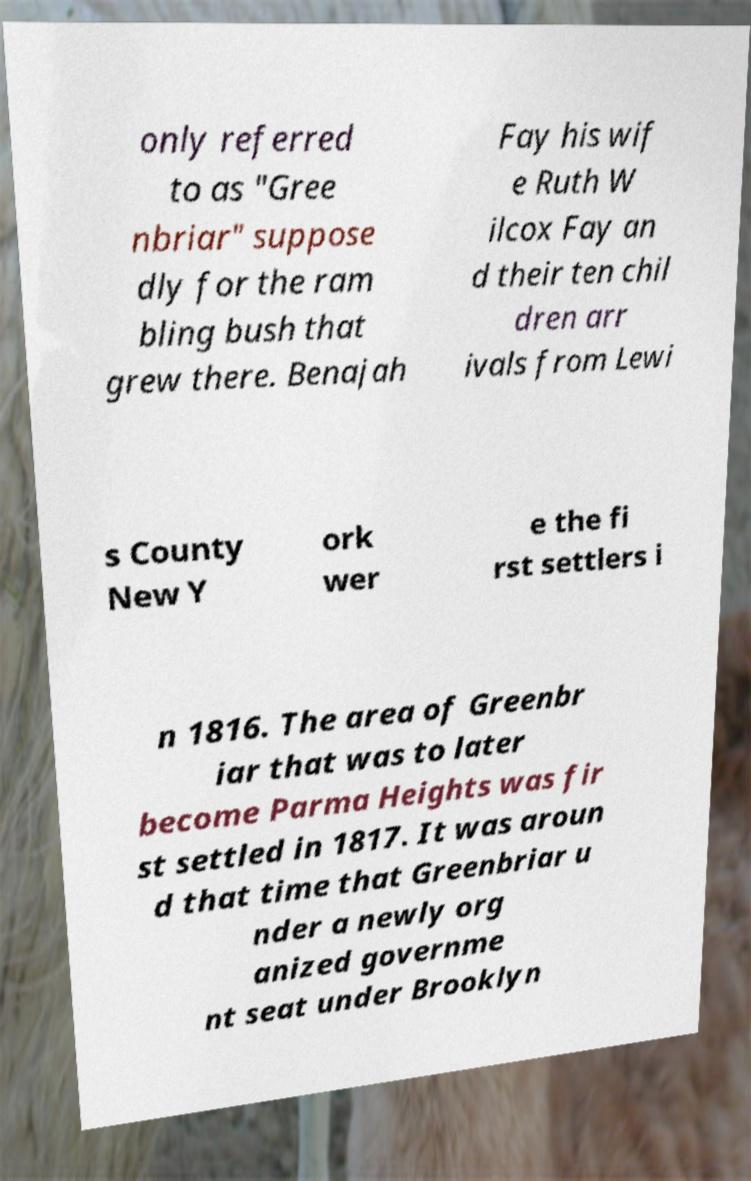There's text embedded in this image that I need extracted. Can you transcribe it verbatim? only referred to as "Gree nbriar" suppose dly for the ram bling bush that grew there. Benajah Fay his wif e Ruth W ilcox Fay an d their ten chil dren arr ivals from Lewi s County New Y ork wer e the fi rst settlers i n 1816. The area of Greenbr iar that was to later become Parma Heights was fir st settled in 1817. It was aroun d that time that Greenbriar u nder a newly org anized governme nt seat under Brooklyn 